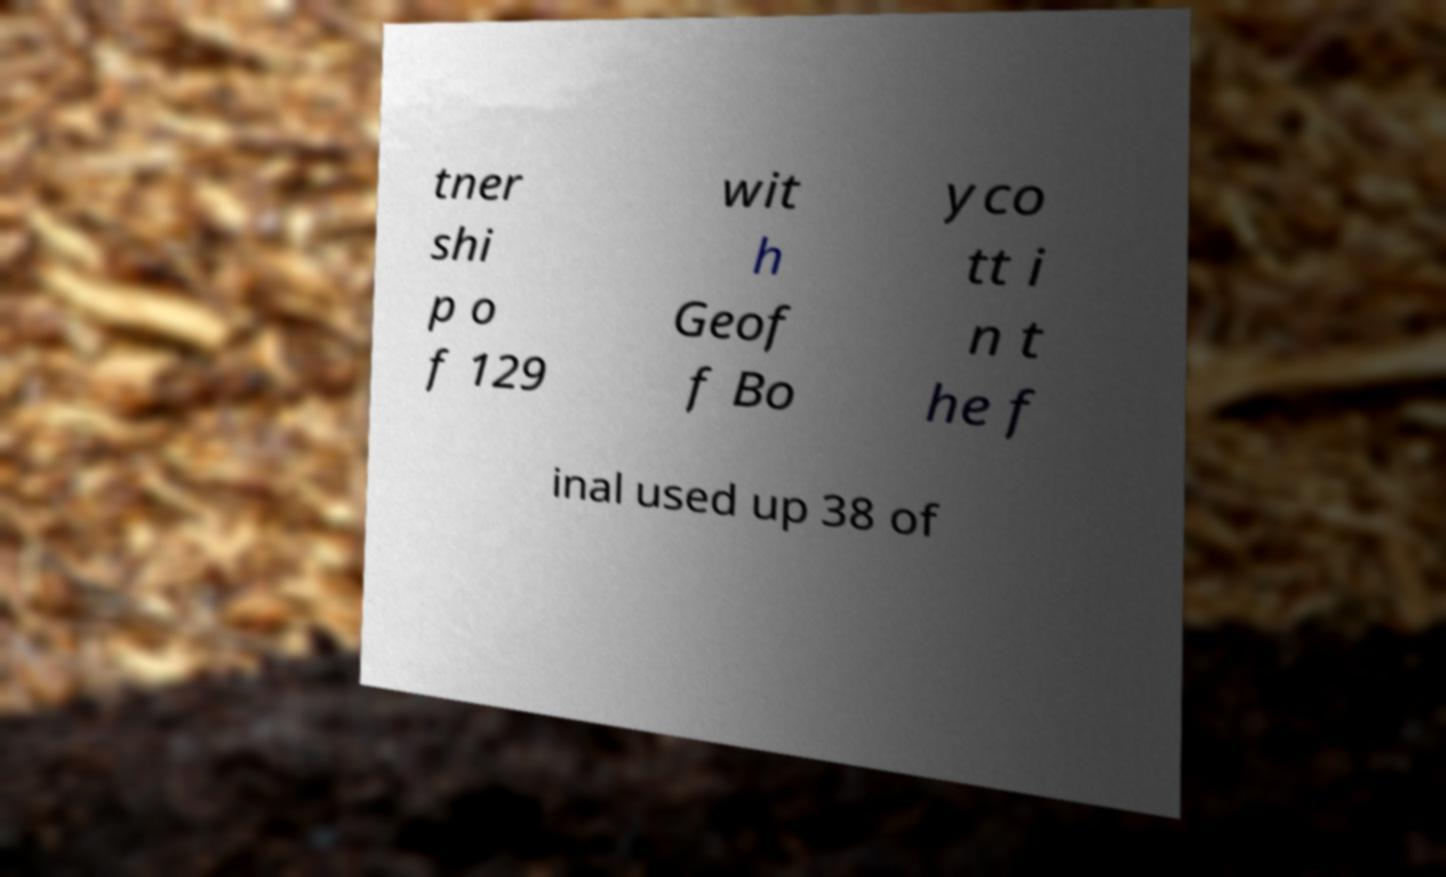There's text embedded in this image that I need extracted. Can you transcribe it verbatim? tner shi p o f 129 wit h Geof f Bo yco tt i n t he f inal used up 38 of 